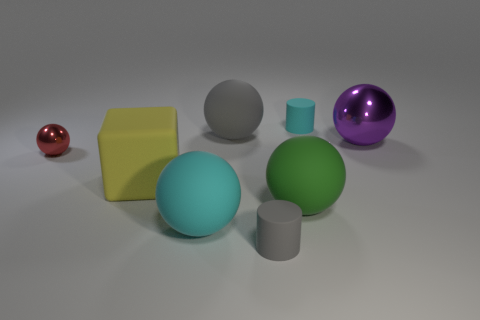Subtract all gray balls. How many balls are left? 4 Subtract all cyan rubber balls. How many balls are left? 4 Subtract all cyan spheres. Subtract all gray blocks. How many spheres are left? 4 Add 1 rubber balls. How many objects exist? 9 Subtract all cylinders. How many objects are left? 6 Subtract all brown shiny cylinders. Subtract all large gray rubber objects. How many objects are left? 7 Add 5 large rubber blocks. How many large rubber blocks are left? 6 Add 5 yellow blocks. How many yellow blocks exist? 6 Subtract 0 red cylinders. How many objects are left? 8 